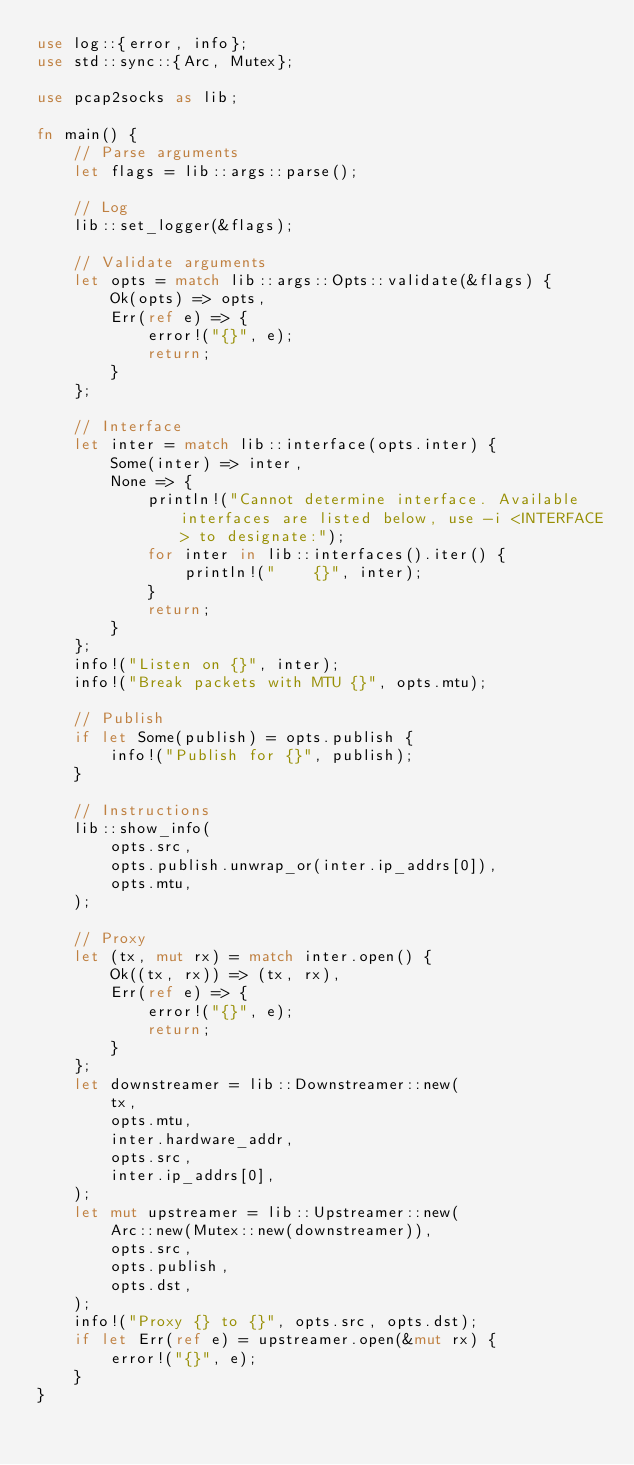<code> <loc_0><loc_0><loc_500><loc_500><_Rust_>use log::{error, info};
use std::sync::{Arc, Mutex};

use pcap2socks as lib;

fn main() {
    // Parse arguments
    let flags = lib::args::parse();

    // Log
    lib::set_logger(&flags);

    // Validate arguments
    let opts = match lib::args::Opts::validate(&flags) {
        Ok(opts) => opts,
        Err(ref e) => {
            error!("{}", e);
            return;
        }
    };

    // Interface
    let inter = match lib::interface(opts.inter) {
        Some(inter) => inter,
        None => {
            println!("Cannot determine interface. Available interfaces are listed below, use -i <INTERFACE> to designate:");
            for inter in lib::interfaces().iter() {
                println!("    {}", inter);
            }
            return;
        }
    };
    info!("Listen on {}", inter);
    info!("Break packets with MTU {}", opts.mtu);

    // Publish
    if let Some(publish) = opts.publish {
        info!("Publish for {}", publish);
    }

    // Instructions
    lib::show_info(
        opts.src,
        opts.publish.unwrap_or(inter.ip_addrs[0]),
        opts.mtu,
    );

    // Proxy
    let (tx, mut rx) = match inter.open() {
        Ok((tx, rx)) => (tx, rx),
        Err(ref e) => {
            error!("{}", e);
            return;
        }
    };
    let downstreamer = lib::Downstreamer::new(
        tx,
        opts.mtu,
        inter.hardware_addr,
        opts.src,
        inter.ip_addrs[0],
    );
    let mut upstreamer = lib::Upstreamer::new(
        Arc::new(Mutex::new(downstreamer)),
        opts.src,
        opts.publish,
        opts.dst,
    );
    info!("Proxy {} to {}", opts.src, opts.dst);
    if let Err(ref e) = upstreamer.open(&mut rx) {
        error!("{}", e);
    }
}
</code> 